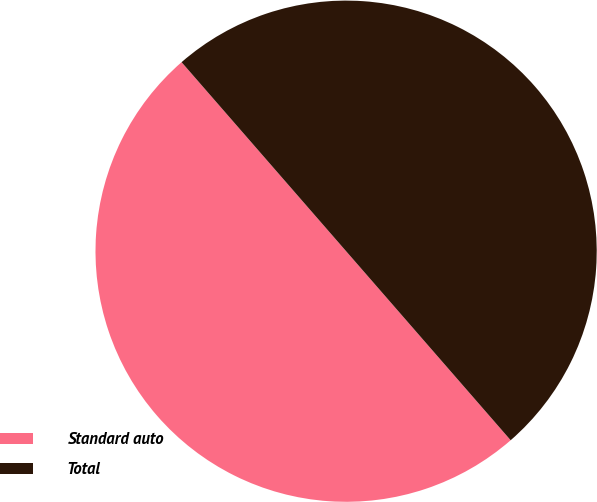<chart> <loc_0><loc_0><loc_500><loc_500><pie_chart><fcel>Standard auto<fcel>Total<nl><fcel>50.0%<fcel>50.0%<nl></chart> 